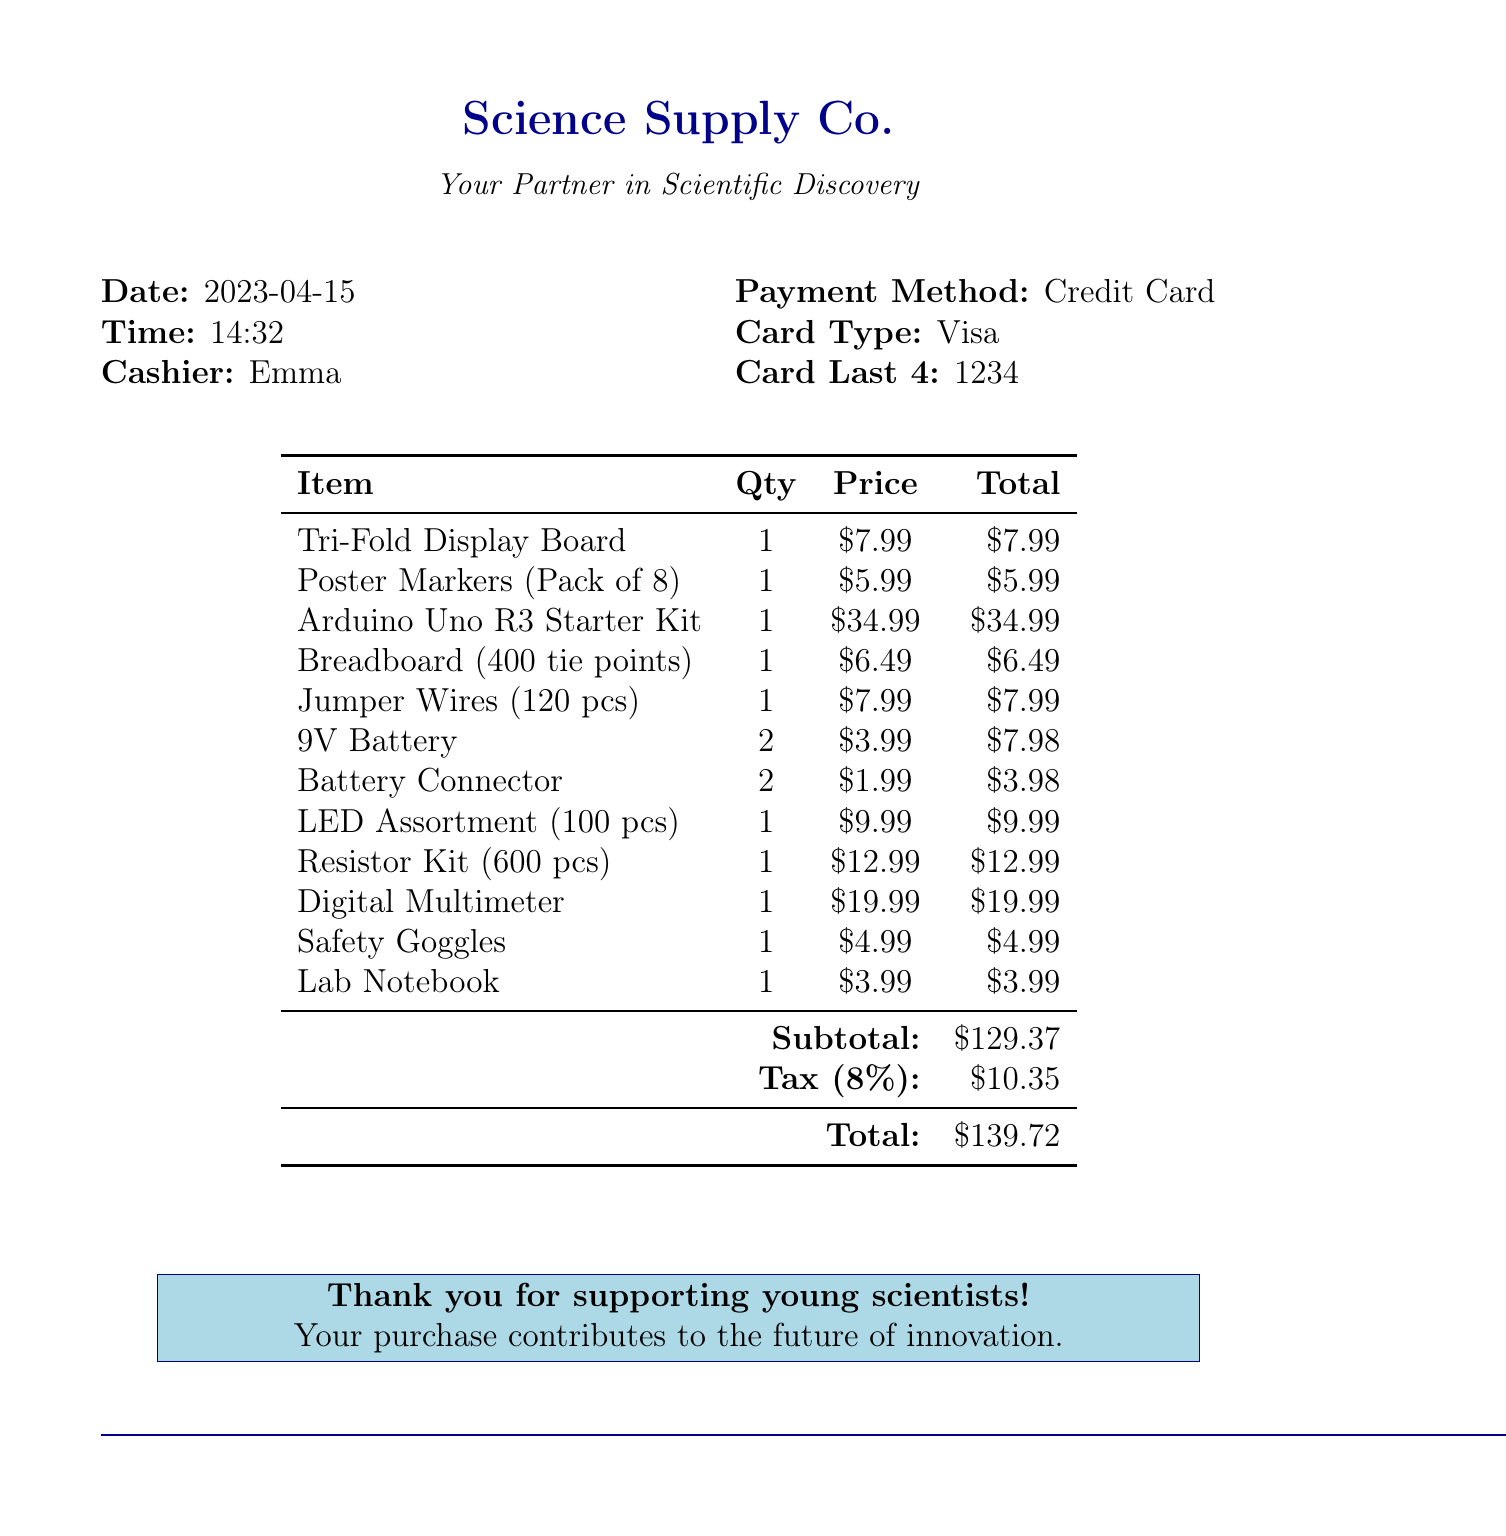What is the store name? The store name is provided at the top of the document and is "Science Supply Co."
Answer: Science Supply Co What is the date of purchase? The date of purchase is listed in the document as "2023-04-15."
Answer: 2023-04-15 How much did the Arduino Uno R3 Starter Kit cost? The price of the Arduino Uno R3 Starter Kit is specifically mentioned in the itemized list, which is $34.99.
Answer: $34.99 What was the total amount paid? The total amount paid is listed at the bottom of the receipt, which includes tax and is $139.72.
Answer: $139.72 How many 9V batteries were purchased? The quantity of 9V batteries is stated in the document as 2.
Answer: 2 What is the subtotal before tax? The subtotal before tax is indicated in the document as $129.37.
Answer: $129.37 What payment method was used? The payment method is mentioned in the document as "Credit Card."
Answer: Credit Card Who was the cashier at the time of purchase? The name of the cashier is provided in the document as "Emma."
Answer: Emma What type of goggles were purchased? The item purchased is labeled as "Safety Goggles" in the receipt.
Answer: Safety Goggles 